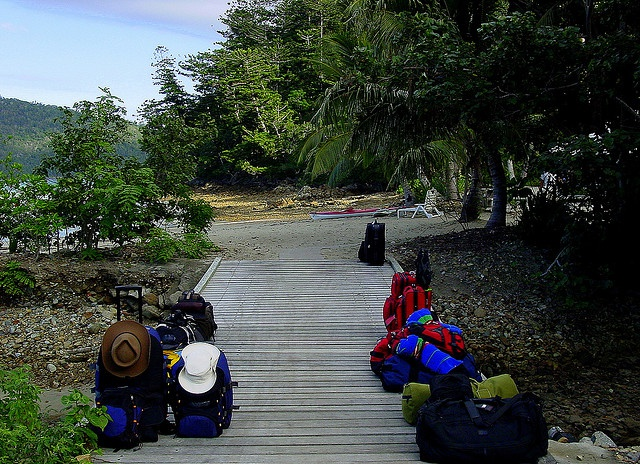Describe the objects in this image and their specific colors. I can see suitcase in lightblue, black, navy, gray, and blue tones, backpack in lightblue, black, lightgray, navy, and darkgray tones, suitcase in lightblue, black, navy, gray, and maroon tones, backpack in lightblue, black, brown, maroon, and navy tones, and backpack in lightblue, black, gray, darkgray, and lightgray tones in this image. 